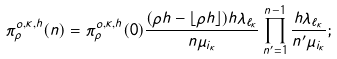Convert formula to latex. <formula><loc_0><loc_0><loc_500><loc_500>\pi _ { \rho } ^ { o , \kappa , h } ( n ) = \pi _ { \rho } ^ { o , \kappa , h } ( 0 ) \frac { ( \rho h - \lfloor \rho h \rfloor ) h \lambda _ { \ell _ { \kappa } } } { n \mu _ { i _ { \kappa } } } \prod _ { n ^ { \prime } = 1 } ^ { n - 1 } \frac { h \lambda _ { \ell _ { \kappa } } } { n ^ { \prime } \mu _ { i _ { \kappa } } } ;</formula> 